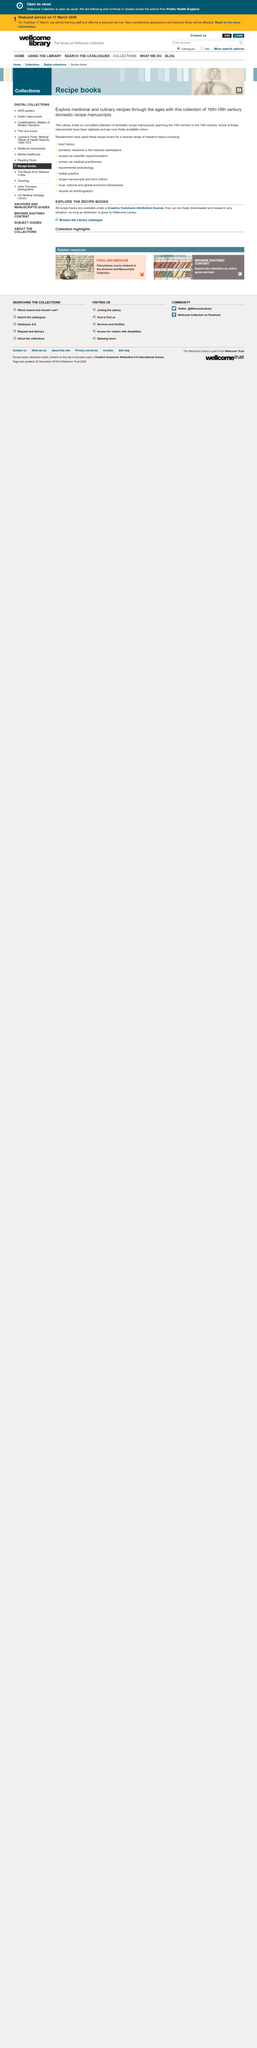Outline some significant characteristics in this image. Some of the manuscripts have been digitized and are now freely available online. The collection of manuscripts provides a rich source for exploring the evolution of medicinal and culinary recipes throughout history. The collection of domestic recipe manuscripts is from the 16th-19th centuries. 